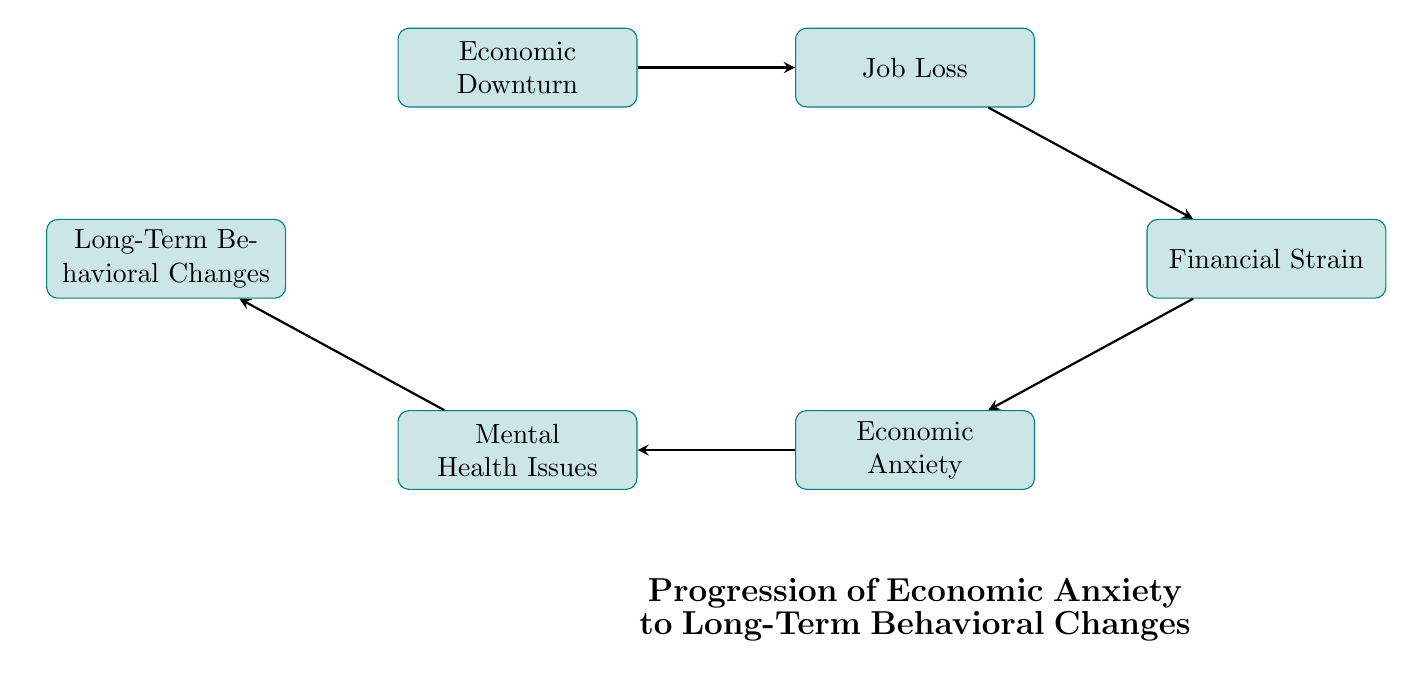What is the first node in the flow chart? The first node is "Economic Downturn," which is the starting point of the flow chart.
Answer: Economic Downturn How many nodes are in the flow chart? The flow chart contains a total of 6 nodes, which represent different stages of progression regarding economic issues and their effects.
Answer: 6 What follows "Job Loss" in the flow chart? "Job Loss" is followed by "Financial Strain," indicating the direct consequence of losing a job.
Answer: Financial Strain Which node is linked directly to "Economic Anxiety"? "Economic Anxiety" is linked directly to "Mental Health Issues," showing the progression from anxiety to potential mental health impacts.
Answer: Mental Health Issues What is the final node in the flow chart? The final node is "Long-Term Behavioral Changes," which represents the last outcome in the progression depicted in the flow chart.
Answer: Long-Term Behavioral Changes What is the relationship between "Financial Strain" and "Economic Anxiety"? "Financial Strain" leads to "Economic Anxiety," demonstrating a cause-and-effect relationship where financial difficulties contribute to anxiety.
Answer: Leads to Which node has the most connections, based on the flow chart? The node "Mental Health Issues" has one outgoing connection to "Long-Term Behavioral Changes," while "Financial Strain" and "Economic Anxiety" also have one outgoing connection. Thus, all these nodes are interconnected, but "Mental Health Issues" marks a significant transition point.
Answer: Mental Health Issues What progression does the flow chart depict overall? The flow chart depicts the progression from "Economic Downturn" leading to a series of consequences—job loss, financial strain, anxiety, mental health issues, and ultimately behavioral changes.
Answer: Economic Downturn to Behavioral Changes Identify the intermediary node between "Job Loss" and "Economic Anxiety." The intermediary node is "Financial Strain," which acts as a bridge between job loss and the resulting anxiety felt by individuals.
Answer: Financial Strain What type of diagram is represented here? The diagram is a flow chart that illustrates the progression of economic anxiety leading to behavioral changes over time.
Answer: Flow chart 